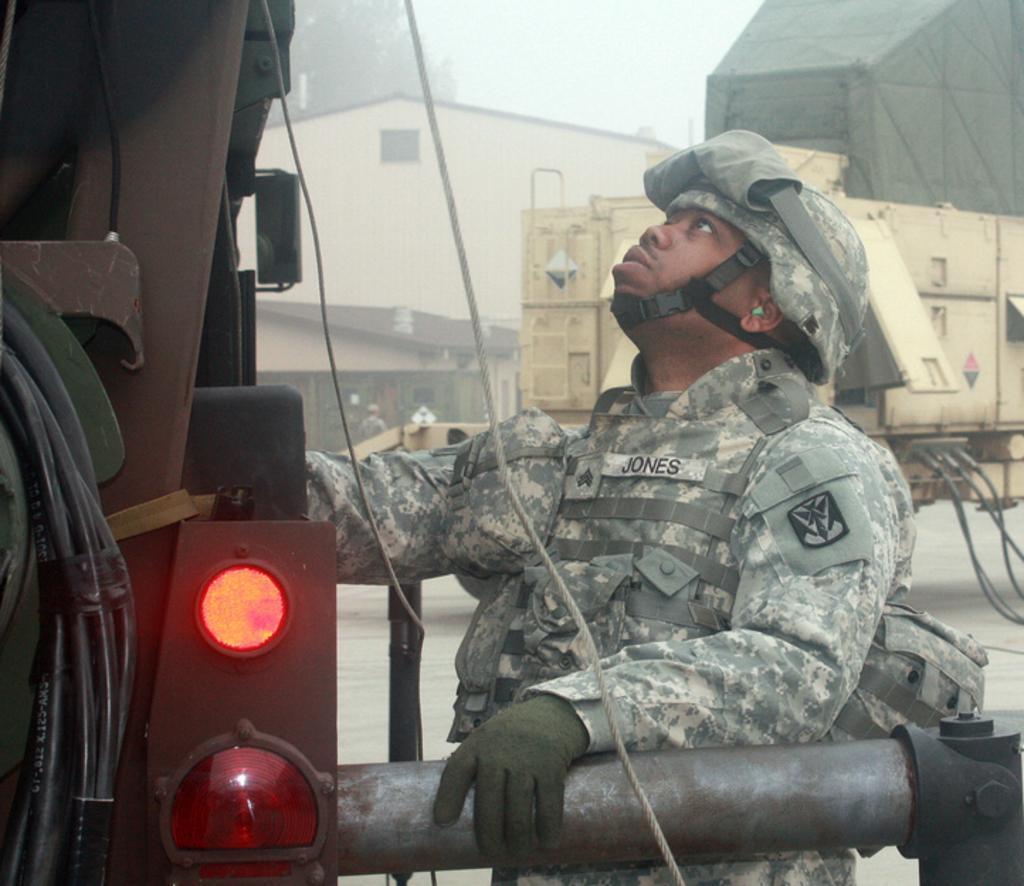In one or two sentences, can you explain what this image depicts? In this picture I can see a building and few people standing and a man operating a machine and he wore a cap on his head and gloves to his hands and we see another machine on the side and i can see trees and a cloudy sky. 